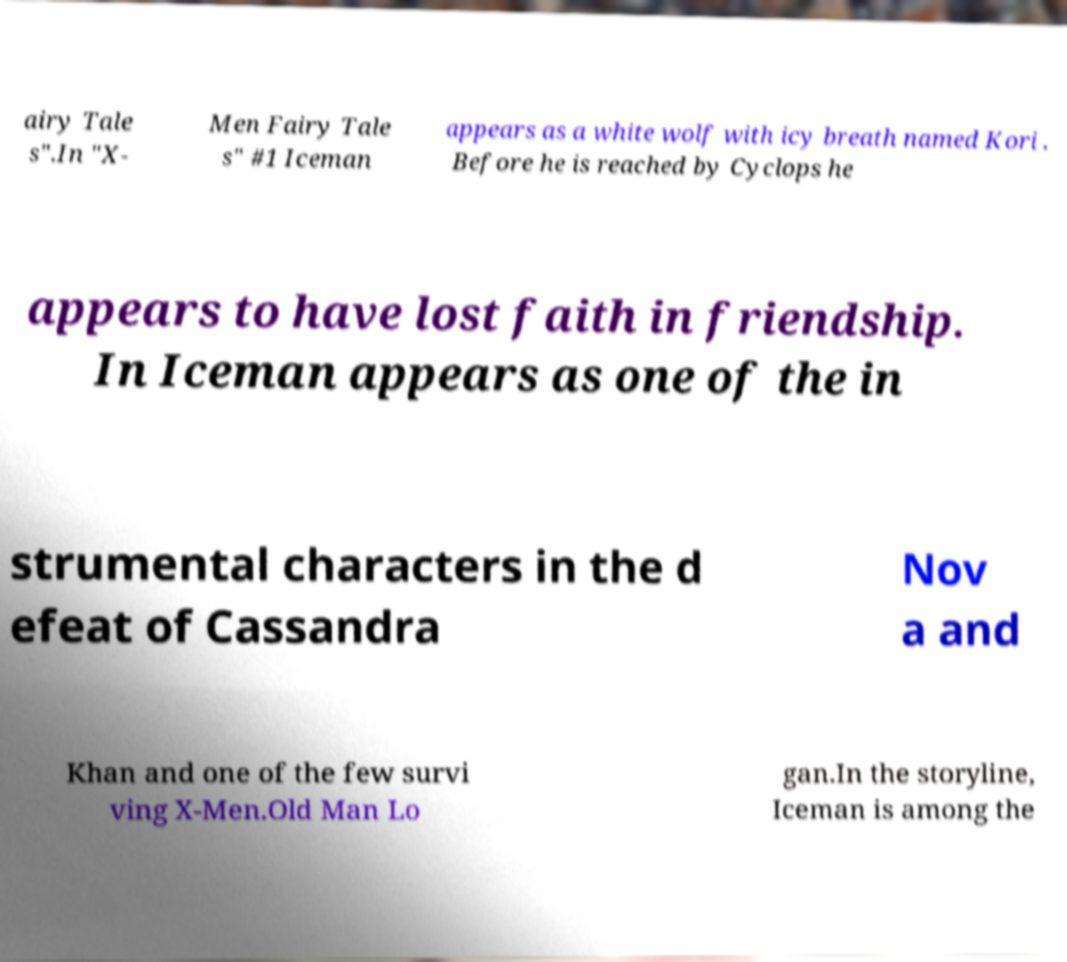Can you accurately transcribe the text from the provided image for me? airy Tale s".In "X- Men Fairy Tale s" #1 Iceman appears as a white wolf with icy breath named Kori . Before he is reached by Cyclops he appears to have lost faith in friendship. In Iceman appears as one of the in strumental characters in the d efeat of Cassandra Nov a and Khan and one of the few survi ving X-Men.Old Man Lo gan.In the storyline, Iceman is among the 